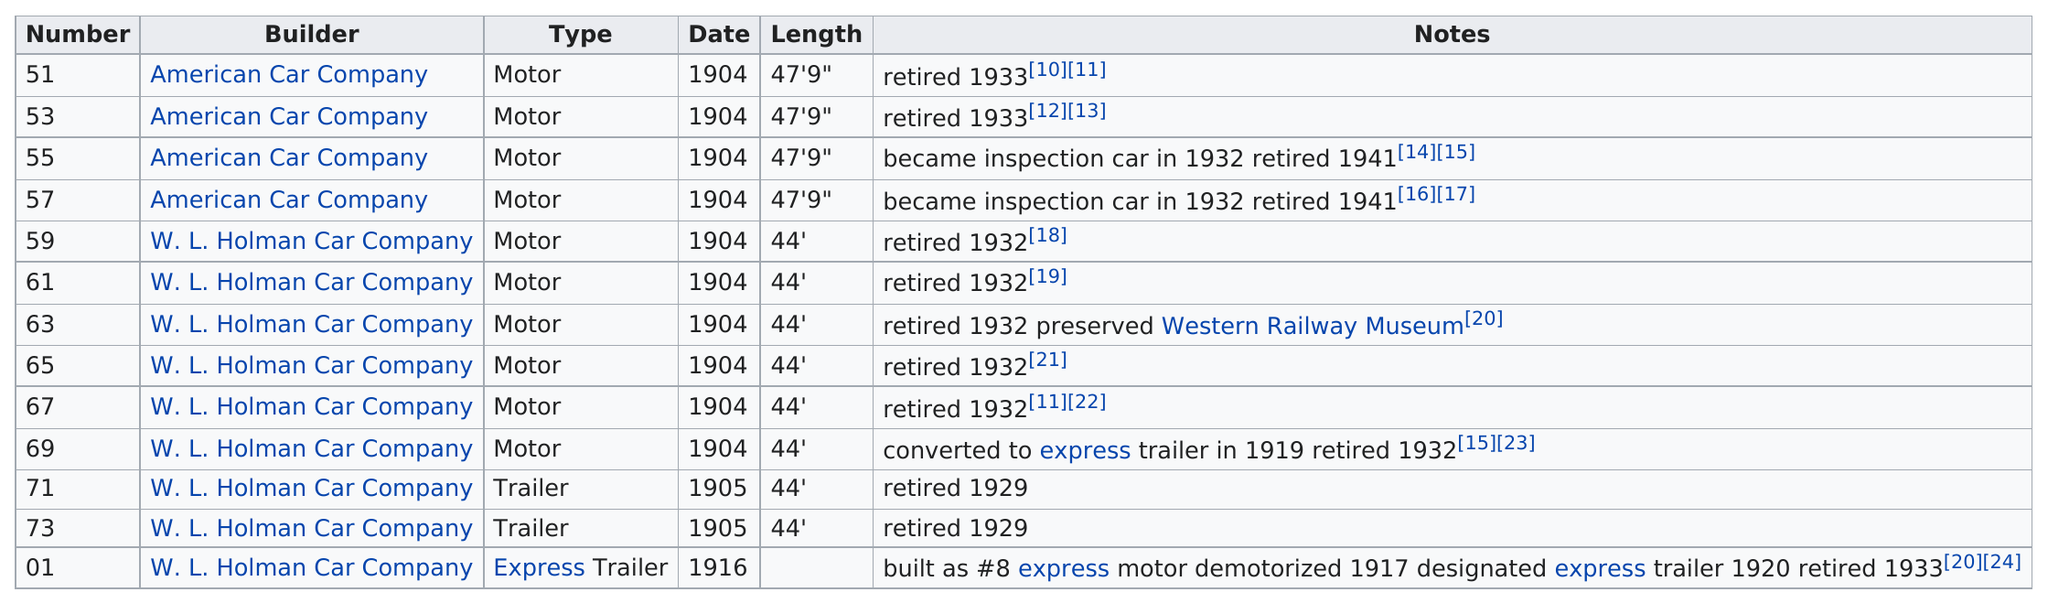Outline some significant characteristics in this image. The time it took for person number 71 to retire was 24 hours. The W.L. Holman Car Company built the most cars out of all the builders. The total number of cars listed was 13. The number of cars built by an American car company was 4. It is unclear whether an American car company or the W.L. Holman Car Company built cars that were 44' in length, as the information provided is insufficient. Further research is necessary to determine this fact. 